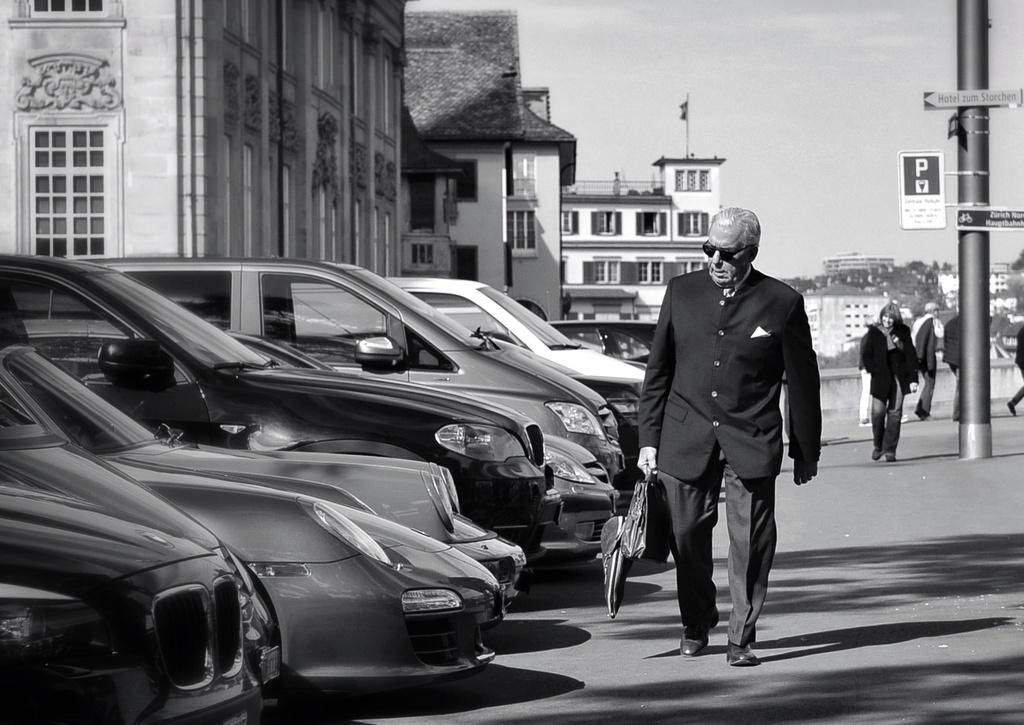What is the color scheme of the image? The image is black and white. What can be seen happening on the road in the image? There are people walking on the road. Where are the cars located in the image? Cars are parked in a row on the left side of the image. What is visible behind the parked cars? There are many buildings behind the parked cars. What type of pest can be seen flying over the parked cars in the image? There are no pests visible in the image, and no flying objects are mentioned in the facts provided. 